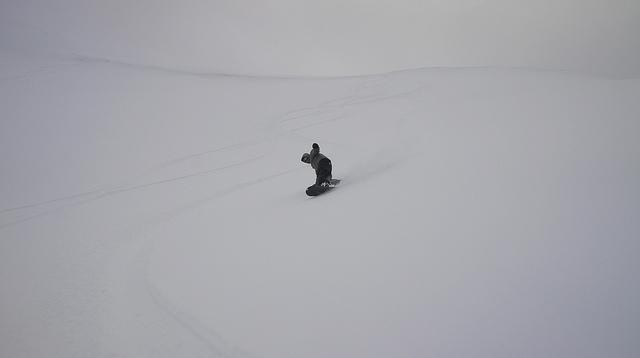What is the person doing?
Write a very short answer. Snowboarding. What is the person in the picture riding?
Give a very brief answer. Snowboard. What color is the snowboard?
Write a very short answer. Black. Would this break if dropped on concrete?
Keep it brief. No. What sport is the person playing?
Quick response, please. Snowboarding. Is the ground full of snow?
Short answer required. Yes. Is the man wearing light clothing?
Be succinct. No. What is the man doing?
Keep it brief. Snowboarding. Are there wires?
Write a very short answer. No. What sport is this?
Give a very brief answer. Snowboarding. 